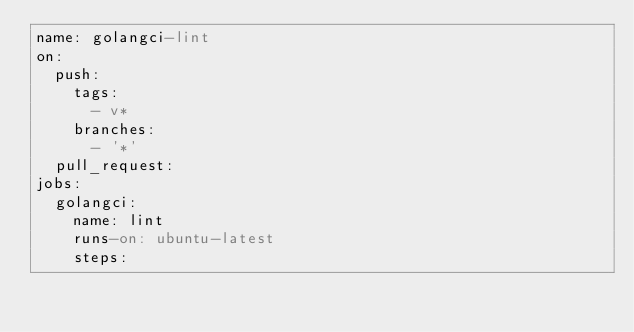Convert code to text. <code><loc_0><loc_0><loc_500><loc_500><_YAML_>name: golangci-lint
on:
  push:
    tags:
      - v*
    branches:
      - '*'
  pull_request:
jobs:
  golangci:
    name: lint
    runs-on: ubuntu-latest
    steps:</code> 